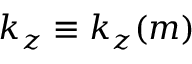Convert formula to latex. <formula><loc_0><loc_0><loc_500><loc_500>k _ { z } \equiv k _ { z } ( m )</formula> 